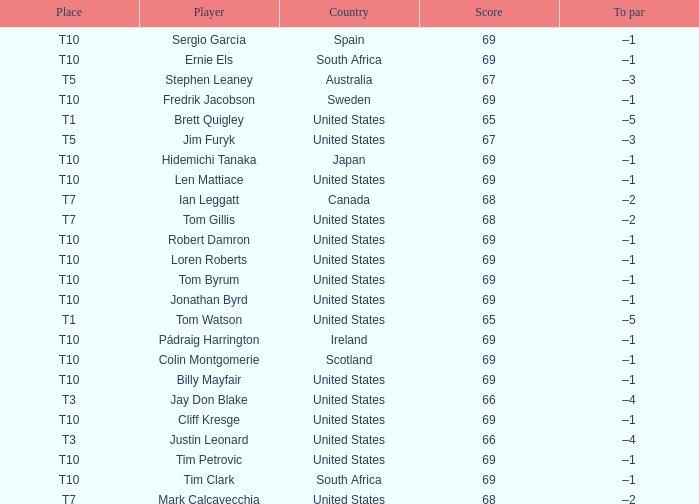Could you parse the entire table? {'header': ['Place', 'Player', 'Country', 'Score', 'To par'], 'rows': [['T10', 'Sergio García', 'Spain', '69', '–1'], ['T10', 'Ernie Els', 'South Africa', '69', '–1'], ['T5', 'Stephen Leaney', 'Australia', '67', '–3'], ['T10', 'Fredrik Jacobson', 'Sweden', '69', '–1'], ['T1', 'Brett Quigley', 'United States', '65', '–5'], ['T5', 'Jim Furyk', 'United States', '67', '–3'], ['T10', 'Hidemichi Tanaka', 'Japan', '69', '–1'], ['T10', 'Len Mattiace', 'United States', '69', '–1'], ['T7', 'Ian Leggatt', 'Canada', '68', '–2'], ['T7', 'Tom Gillis', 'United States', '68', '–2'], ['T10', 'Robert Damron', 'United States', '69', '–1'], ['T10', 'Loren Roberts', 'United States', '69', '–1'], ['T10', 'Tom Byrum', 'United States', '69', '–1'], ['T10', 'Jonathan Byrd', 'United States', '69', '–1'], ['T1', 'Tom Watson', 'United States', '65', '–5'], ['T10', 'Pádraig Harrington', 'Ireland', '69', '–1'], ['T10', 'Colin Montgomerie', 'Scotland', '69', '–1'], ['T10', 'Billy Mayfair', 'United States', '69', '–1'], ['T3', 'Jay Don Blake', 'United States', '66', '–4'], ['T10', 'Cliff Kresge', 'United States', '69', '–1'], ['T3', 'Justin Leonard', 'United States', '66', '–4'], ['T10', 'Tim Petrovic', 'United States', '69', '–1'], ['T10', 'Tim Clark', 'South Africa', '69', '–1'], ['T7', 'Mark Calcavecchia', 'United States', '68', '–2']]} Which player is T3? Jay Don Blake, Justin Leonard. 